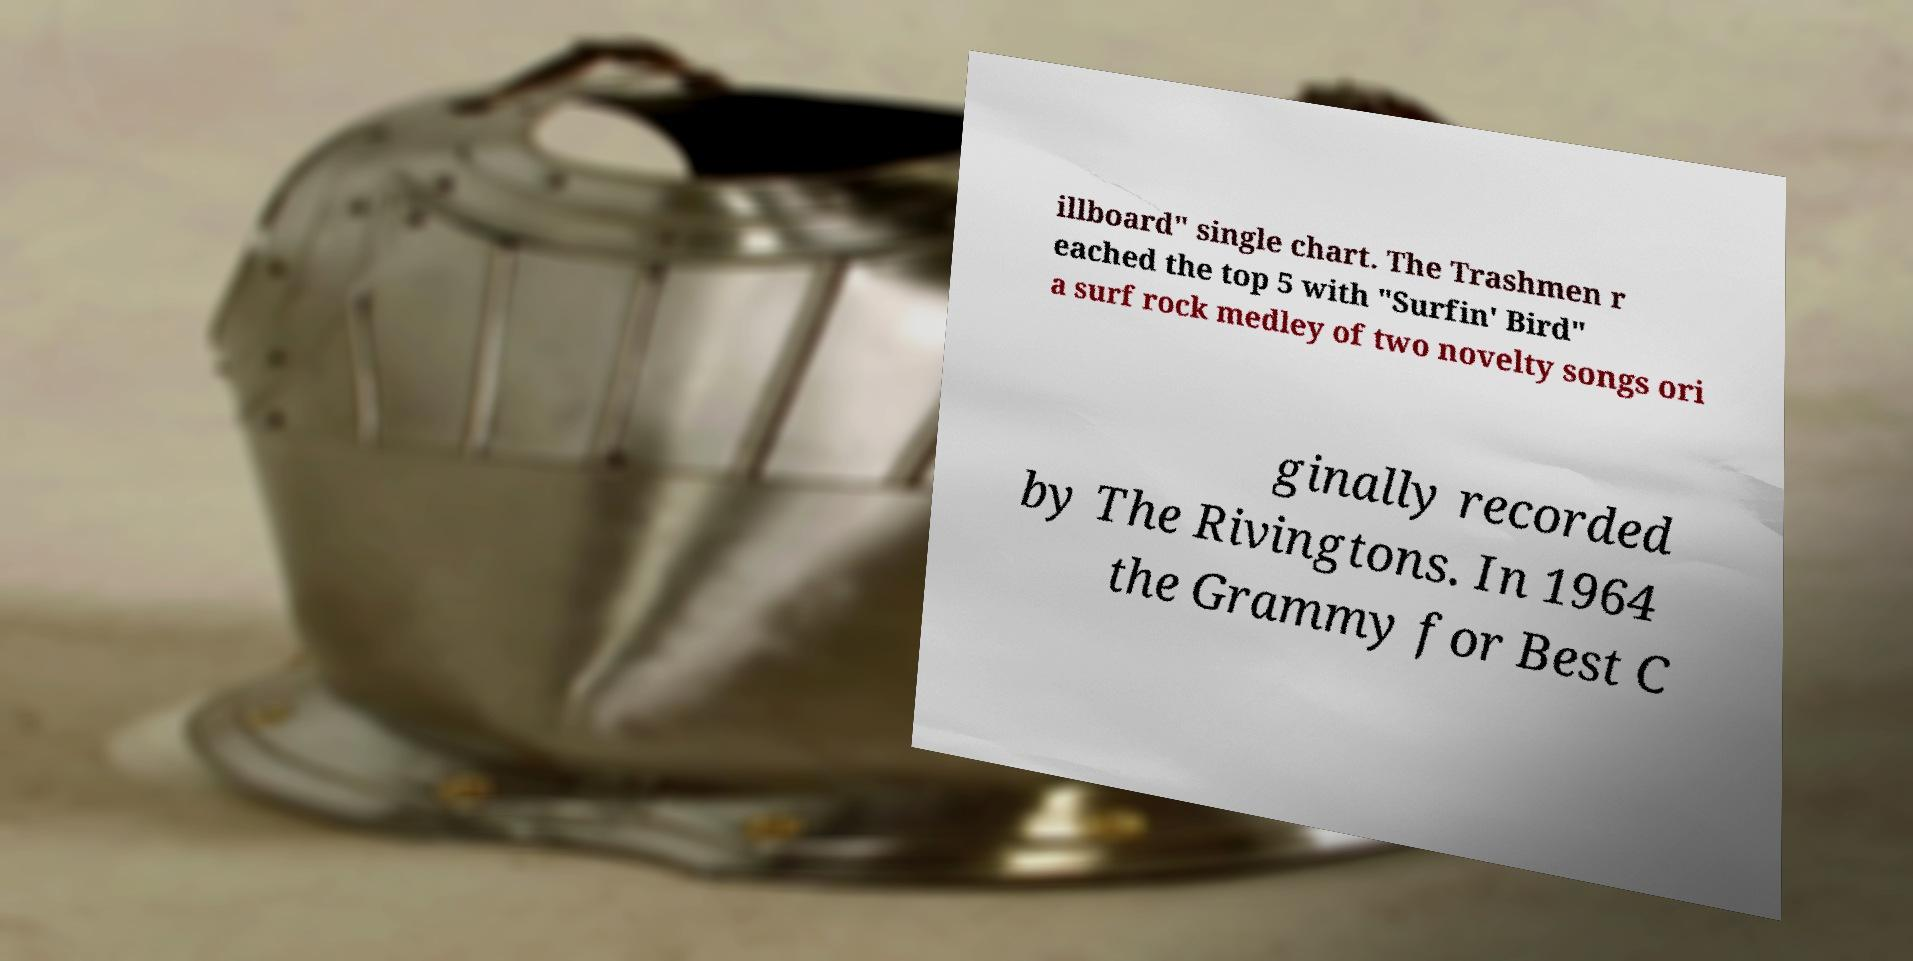There's text embedded in this image that I need extracted. Can you transcribe it verbatim? illboard" single chart. The Trashmen r eached the top 5 with "Surfin' Bird" a surf rock medley of two novelty songs ori ginally recorded by The Rivingtons. In 1964 the Grammy for Best C 